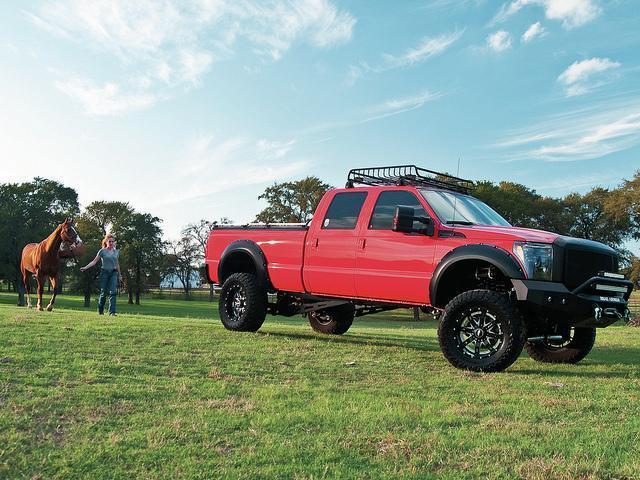How many wheels do this vehicle have?
Give a very brief answer. 4. 